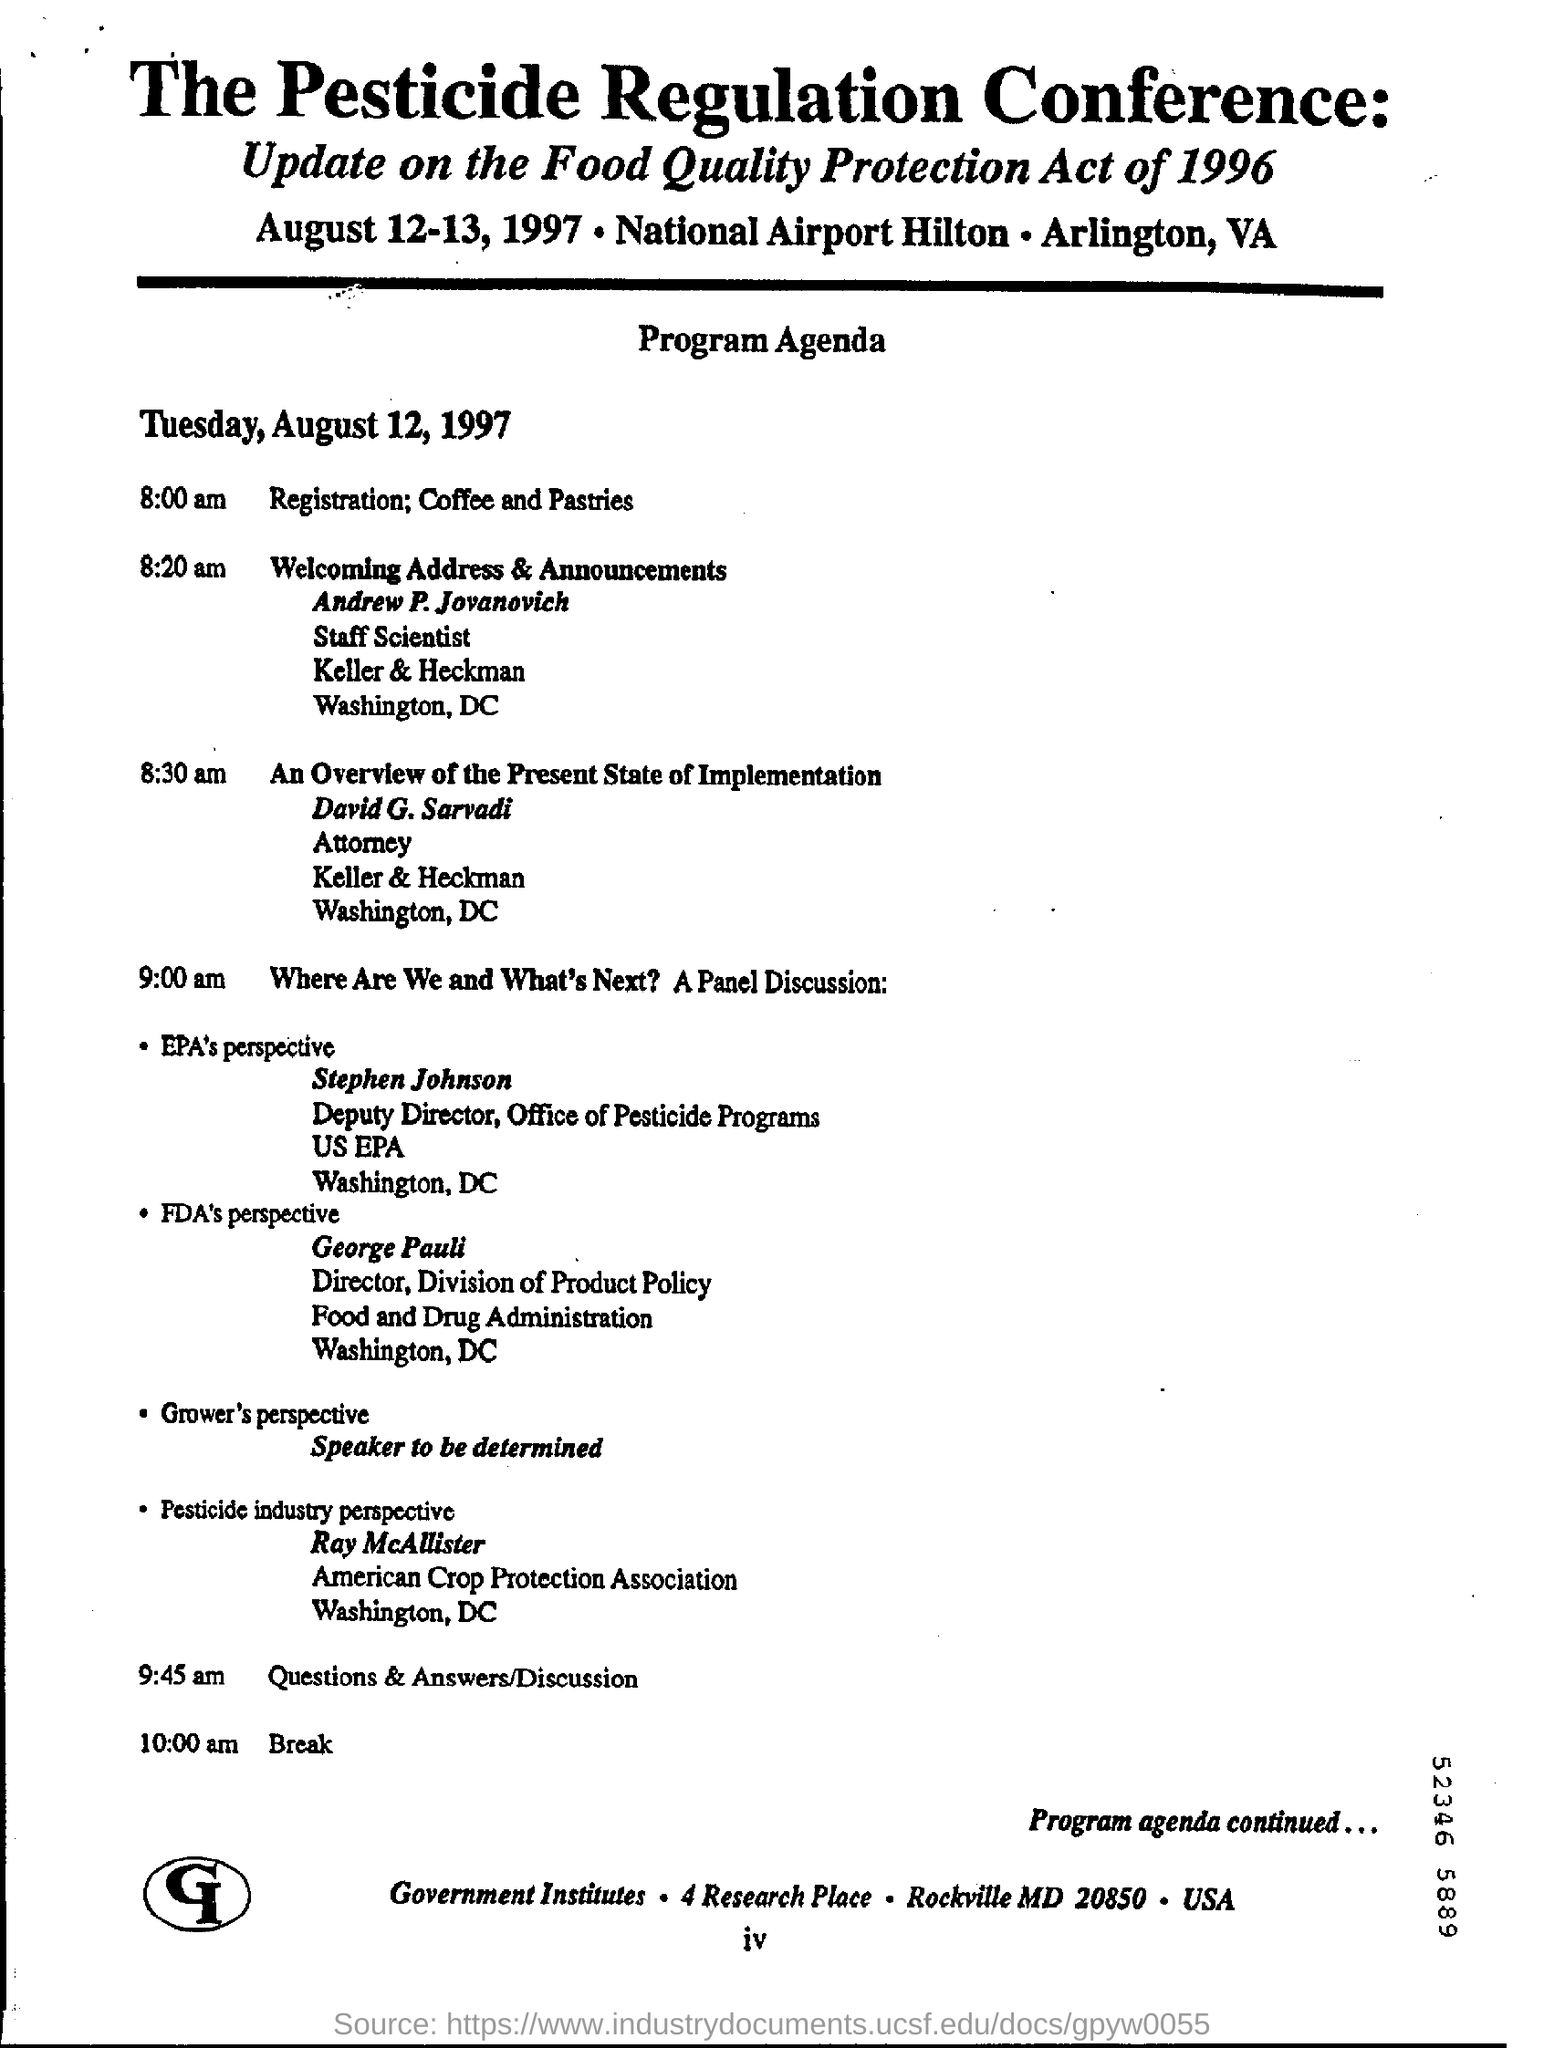Indicate a few pertinent items in this graphic. The event scheduled for 9:45 am is a question and answer/discussion event. The Pesticide Regulation Conference is its name. The registration will commence at 8:00 am. Andrew P. Jovanovich is a Staff Scientist at the company. 